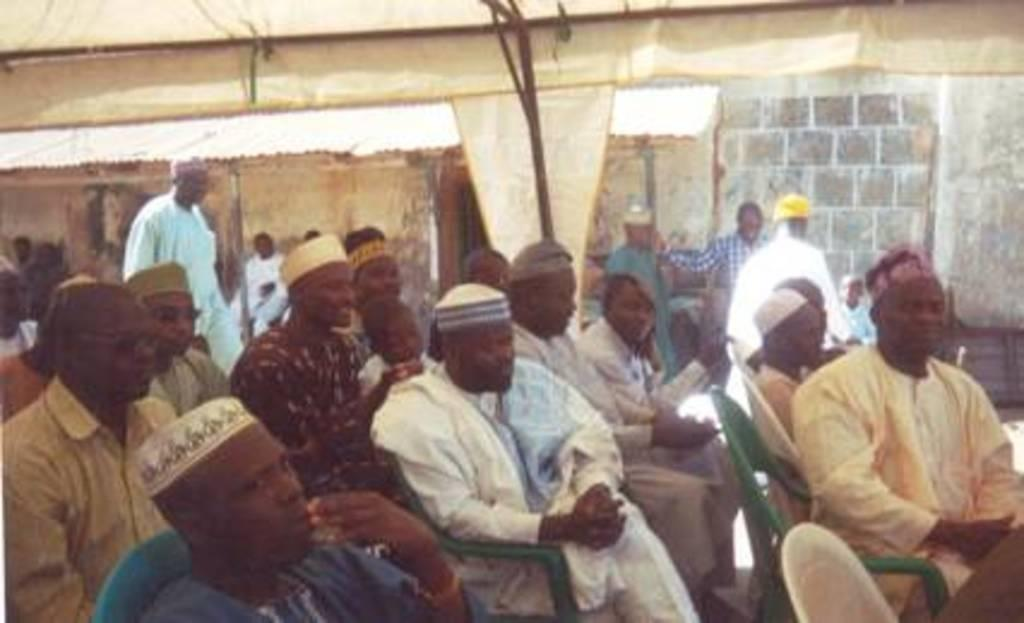How many people are in the image? There is a group of people in the image. What are some of the people in the image doing? Some people are sitting on chairs, while others are standing. What can be seen in the background of the image? There is a wall in the background of the image. What type of crayon is being used by the farmer in the image? There is no farmer or crayon present in the image. What is the farmer painting on the canvas in the image? There is no farmer or canvas present in the image. 